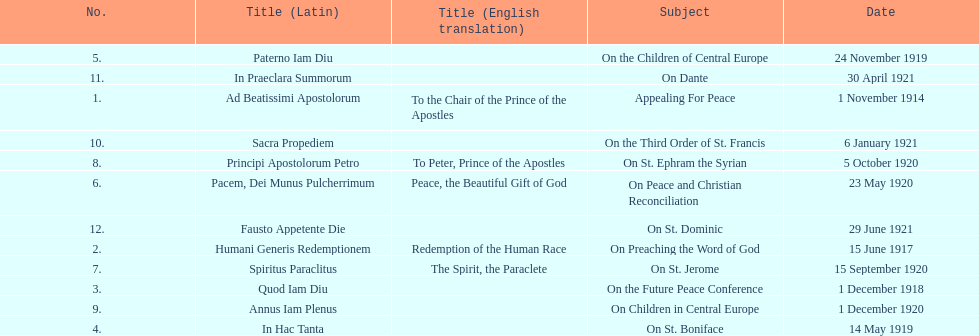After december 1, 1918, on which date was the next encyclical released? 14 May 1919. 